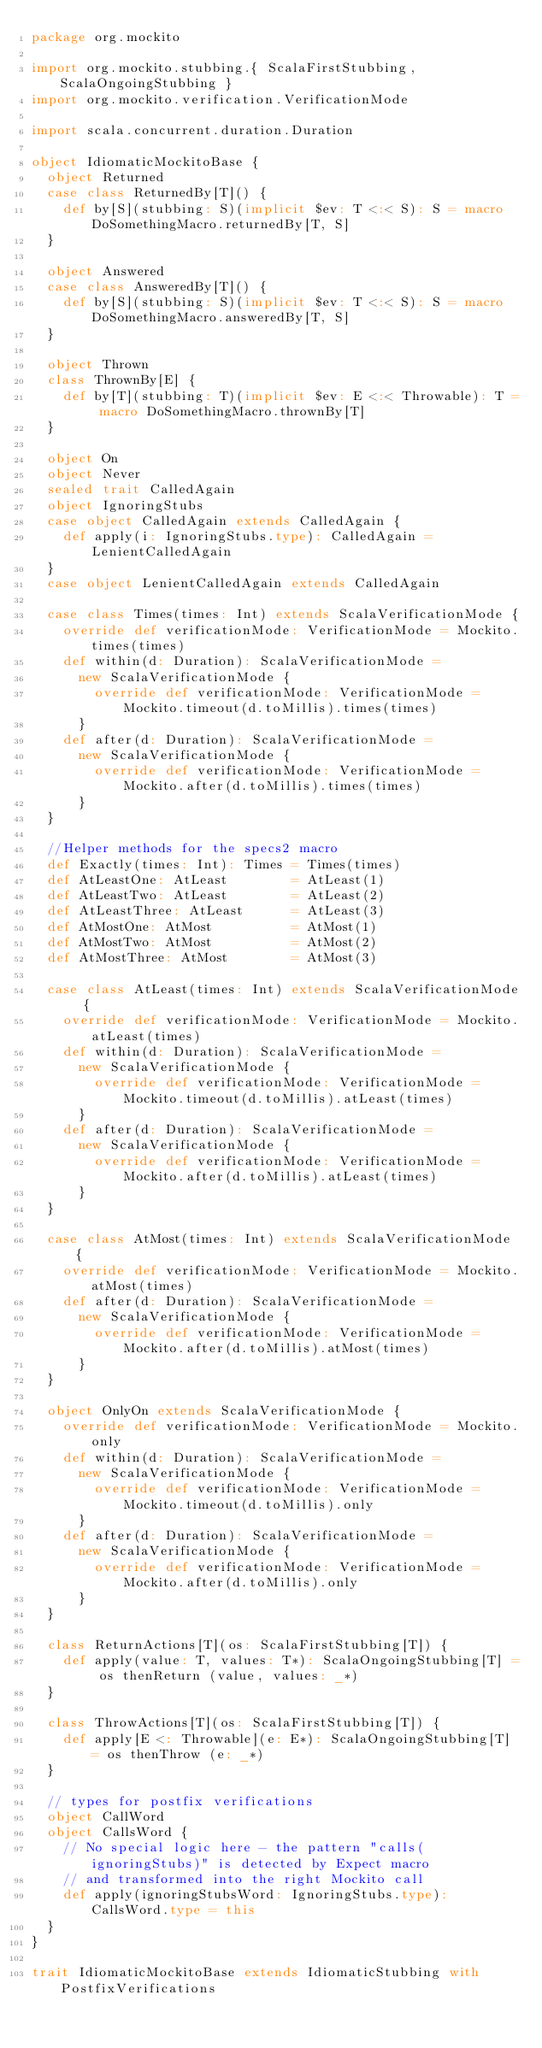<code> <loc_0><loc_0><loc_500><loc_500><_Scala_>package org.mockito

import org.mockito.stubbing.{ ScalaFirstStubbing, ScalaOngoingStubbing }
import org.mockito.verification.VerificationMode

import scala.concurrent.duration.Duration

object IdiomaticMockitoBase {
  object Returned
  case class ReturnedBy[T]() {
    def by[S](stubbing: S)(implicit $ev: T <:< S): S = macro DoSomethingMacro.returnedBy[T, S]
  }

  object Answered
  case class AnsweredBy[T]() {
    def by[S](stubbing: S)(implicit $ev: T <:< S): S = macro DoSomethingMacro.answeredBy[T, S]
  }

  object Thrown
  class ThrownBy[E] {
    def by[T](stubbing: T)(implicit $ev: E <:< Throwable): T = macro DoSomethingMacro.thrownBy[T]
  }

  object On
  object Never
  sealed trait CalledAgain
  object IgnoringStubs
  case object CalledAgain extends CalledAgain {
    def apply(i: IgnoringStubs.type): CalledAgain = LenientCalledAgain
  }
  case object LenientCalledAgain extends CalledAgain

  case class Times(times: Int) extends ScalaVerificationMode {
    override def verificationMode: VerificationMode = Mockito.times(times)
    def within(d: Duration): ScalaVerificationMode =
      new ScalaVerificationMode {
        override def verificationMode: VerificationMode = Mockito.timeout(d.toMillis).times(times)
      }
    def after(d: Duration): ScalaVerificationMode =
      new ScalaVerificationMode {
        override def verificationMode: VerificationMode = Mockito.after(d.toMillis).times(times)
      }
  }

  //Helper methods for the specs2 macro
  def Exactly(times: Int): Times = Times(times)
  def AtLeastOne: AtLeast        = AtLeast(1)
  def AtLeastTwo: AtLeast        = AtLeast(2)
  def AtLeastThree: AtLeast      = AtLeast(3)
  def AtMostOne: AtMost          = AtMost(1)
  def AtMostTwo: AtMost          = AtMost(2)
  def AtMostThree: AtMost        = AtMost(3)

  case class AtLeast(times: Int) extends ScalaVerificationMode {
    override def verificationMode: VerificationMode = Mockito.atLeast(times)
    def within(d: Duration): ScalaVerificationMode =
      new ScalaVerificationMode {
        override def verificationMode: VerificationMode = Mockito.timeout(d.toMillis).atLeast(times)
      }
    def after(d: Duration): ScalaVerificationMode =
      new ScalaVerificationMode {
        override def verificationMode: VerificationMode = Mockito.after(d.toMillis).atLeast(times)
      }
  }

  case class AtMost(times: Int) extends ScalaVerificationMode {
    override def verificationMode: VerificationMode = Mockito.atMost(times)
    def after(d: Duration): ScalaVerificationMode =
      new ScalaVerificationMode {
        override def verificationMode: VerificationMode = Mockito.after(d.toMillis).atMost(times)
      }
  }

  object OnlyOn extends ScalaVerificationMode {
    override def verificationMode: VerificationMode = Mockito.only
    def within(d: Duration): ScalaVerificationMode =
      new ScalaVerificationMode {
        override def verificationMode: VerificationMode = Mockito.timeout(d.toMillis).only
      }
    def after(d: Duration): ScalaVerificationMode =
      new ScalaVerificationMode {
        override def verificationMode: VerificationMode = Mockito.after(d.toMillis).only
      }
  }

  class ReturnActions[T](os: ScalaFirstStubbing[T]) {
    def apply(value: T, values: T*): ScalaOngoingStubbing[T] = os thenReturn (value, values: _*)
  }

  class ThrowActions[T](os: ScalaFirstStubbing[T]) {
    def apply[E <: Throwable](e: E*): ScalaOngoingStubbing[T] = os thenThrow (e: _*)
  }

  // types for postfix verifications
  object CallWord
  object CallsWord {
    // No special logic here - the pattern "calls(ignoringStubs)" is detected by Expect macro
    // and transformed into the right Mockito call
    def apply(ignoringStubsWord: IgnoringStubs.type): CallsWord.type = this
  }
}

trait IdiomaticMockitoBase extends IdiomaticStubbing with PostfixVerifications
</code> 